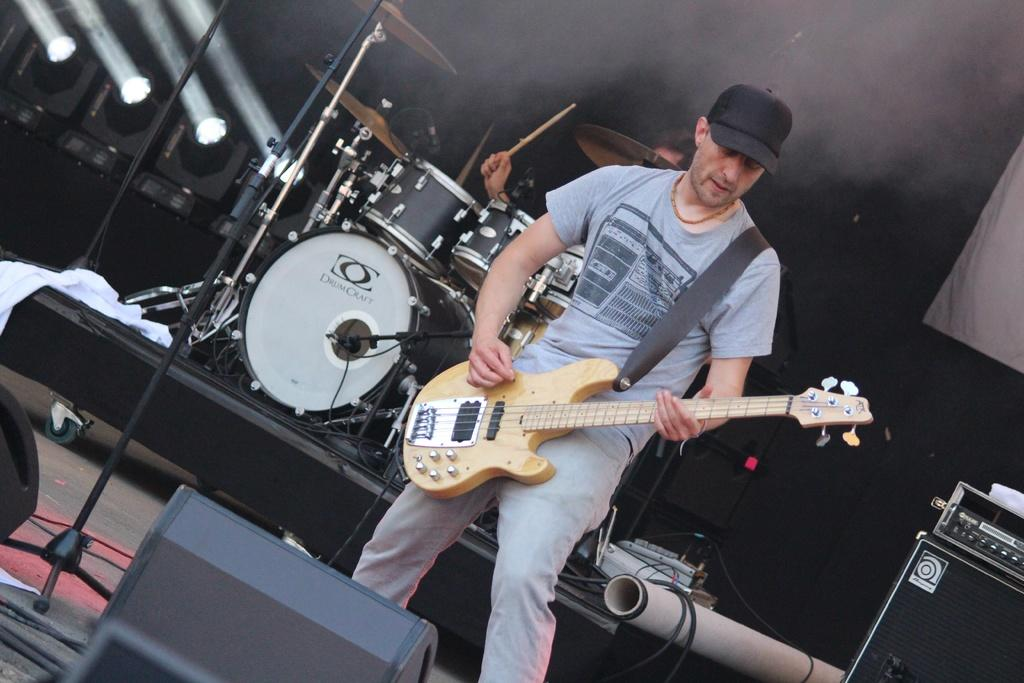What is the main subject of the image? There is a man in the image. What is the man doing in the image? The man is standing and holding a guitar. What can be seen in the background of the image? There is a drum set and a person in the background of the image. What type of beef is being cooked on the grill in the image? There is no grill or beef present in the image; it features a man holding a guitar and a drum set in the background. How many pears are visible on the table in the image? There are no pears present in the image. 